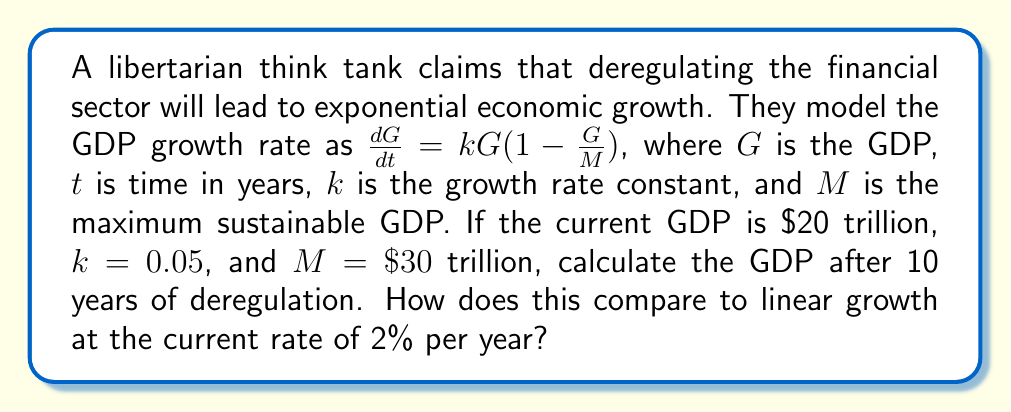Can you answer this question? 1) The given differential equation is a logistic growth model:

   $$\frac{dG}{dt} = kG(1-\frac{G}{M})$$

2) To solve this, we use the logistic function solution:

   $$G(t) = \frac{M}{1 + (\frac{M}{G_0} - 1)e^{-kt}}$$

   where $G_0$ is the initial GDP.

3) Given values:
   $G_0 = \$20$ trillion
   $k = 0.05$
   $M = \$30$ trillion
   $t = 10$ years

4) Plugging these into the equation:

   $$G(10) = \frac{30}{1 + (\frac{30}{20} - 1)e^{-0.05(10)}}$$

5) Simplifying:

   $$G(10) = \frac{30}{1 + 0.5e^{-0.5}} \approx \$26.57 \text{ trillion}$$

6) For comparison, linear growth at 2% per year:

   $$G_{linear}(10) = 20 * (1 + 0.02)^{10} \approx \$24.38 \text{ trillion}$$

7) The difference:

   $$\$26.57 \text{ trillion} - \$24.38 \text{ trillion} = \$2.19 \text{ trillion}$$
Answer: $\$26.57$ trillion; $\$2.19$ trillion higher than linear growth 